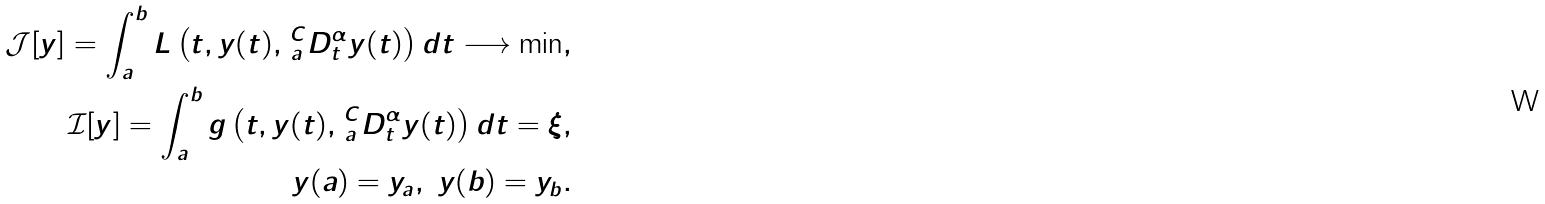Convert formula to latex. <formula><loc_0><loc_0><loc_500><loc_500>\mathcal { J } [ y ] = \int _ { a } ^ { b } L \left ( t , y ( t ) , \, { _ { a } ^ { C } D _ { t } ^ { \alpha } } y ( t ) \right ) d t \longrightarrow \min , \\ \mathcal { I } [ y ] = \int _ { a } ^ { b } g \left ( t , y ( t ) , \, { _ { a } ^ { C } D _ { t } ^ { \alpha } } y ( t ) \right ) d t = \xi , \\ y ( a ) = y _ { a } , \ y ( b ) = y _ { b } .</formula> 